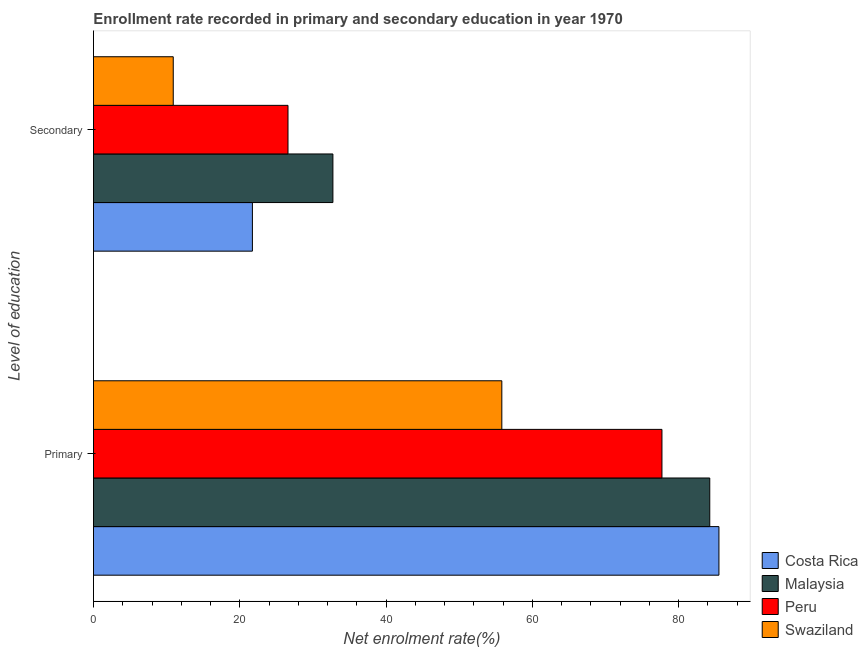How many different coloured bars are there?
Give a very brief answer. 4. How many groups of bars are there?
Offer a very short reply. 2. How many bars are there on the 2nd tick from the bottom?
Your response must be concise. 4. What is the label of the 2nd group of bars from the top?
Your response must be concise. Primary. What is the enrollment rate in secondary education in Malaysia?
Provide a succinct answer. 32.73. Across all countries, what is the maximum enrollment rate in primary education?
Your answer should be very brief. 85.5. Across all countries, what is the minimum enrollment rate in primary education?
Ensure brevity in your answer.  55.82. In which country was the enrollment rate in primary education maximum?
Your answer should be compact. Costa Rica. In which country was the enrollment rate in primary education minimum?
Offer a very short reply. Swaziland. What is the total enrollment rate in primary education in the graph?
Offer a terse response. 303.28. What is the difference between the enrollment rate in secondary education in Costa Rica and that in Malaysia?
Your answer should be very brief. -11. What is the difference between the enrollment rate in secondary education in Costa Rica and the enrollment rate in primary education in Swaziland?
Your response must be concise. -34.09. What is the average enrollment rate in secondary education per country?
Give a very brief answer. 22.99. What is the difference between the enrollment rate in primary education and enrollment rate in secondary education in Malaysia?
Ensure brevity in your answer.  51.51. What is the ratio of the enrollment rate in secondary education in Costa Rica to that in Malaysia?
Your response must be concise. 0.66. In how many countries, is the enrollment rate in secondary education greater than the average enrollment rate in secondary education taken over all countries?
Give a very brief answer. 2. What does the 4th bar from the bottom in Primary represents?
Keep it short and to the point. Swaziland. Are the values on the major ticks of X-axis written in scientific E-notation?
Provide a succinct answer. No. Does the graph contain any zero values?
Your answer should be compact. No. Does the graph contain grids?
Make the answer very short. No. How many legend labels are there?
Provide a succinct answer. 4. What is the title of the graph?
Provide a short and direct response. Enrollment rate recorded in primary and secondary education in year 1970. What is the label or title of the X-axis?
Offer a very short reply. Net enrolment rate(%). What is the label or title of the Y-axis?
Make the answer very short. Level of education. What is the Net enrolment rate(%) of Costa Rica in Primary?
Your answer should be compact. 85.5. What is the Net enrolment rate(%) of Malaysia in Primary?
Give a very brief answer. 84.25. What is the Net enrolment rate(%) in Peru in Primary?
Your answer should be very brief. 77.71. What is the Net enrolment rate(%) in Swaziland in Primary?
Ensure brevity in your answer.  55.82. What is the Net enrolment rate(%) of Costa Rica in Secondary?
Make the answer very short. 21.73. What is the Net enrolment rate(%) of Malaysia in Secondary?
Your answer should be compact. 32.73. What is the Net enrolment rate(%) of Peru in Secondary?
Offer a terse response. 26.59. What is the Net enrolment rate(%) of Swaziland in Secondary?
Your answer should be very brief. 10.9. Across all Level of education, what is the maximum Net enrolment rate(%) of Costa Rica?
Provide a short and direct response. 85.5. Across all Level of education, what is the maximum Net enrolment rate(%) of Malaysia?
Keep it short and to the point. 84.25. Across all Level of education, what is the maximum Net enrolment rate(%) in Peru?
Offer a very short reply. 77.71. Across all Level of education, what is the maximum Net enrolment rate(%) in Swaziland?
Give a very brief answer. 55.82. Across all Level of education, what is the minimum Net enrolment rate(%) of Costa Rica?
Ensure brevity in your answer.  21.73. Across all Level of education, what is the minimum Net enrolment rate(%) in Malaysia?
Offer a terse response. 32.73. Across all Level of education, what is the minimum Net enrolment rate(%) in Peru?
Your answer should be very brief. 26.59. Across all Level of education, what is the minimum Net enrolment rate(%) in Swaziland?
Offer a terse response. 10.9. What is the total Net enrolment rate(%) in Costa Rica in the graph?
Give a very brief answer. 107.23. What is the total Net enrolment rate(%) in Malaysia in the graph?
Offer a terse response. 116.98. What is the total Net enrolment rate(%) in Peru in the graph?
Make the answer very short. 104.3. What is the total Net enrolment rate(%) of Swaziland in the graph?
Offer a terse response. 66.73. What is the difference between the Net enrolment rate(%) of Costa Rica in Primary and that in Secondary?
Give a very brief answer. 63.77. What is the difference between the Net enrolment rate(%) of Malaysia in Primary and that in Secondary?
Your response must be concise. 51.51. What is the difference between the Net enrolment rate(%) in Peru in Primary and that in Secondary?
Your answer should be compact. 51.12. What is the difference between the Net enrolment rate(%) of Swaziland in Primary and that in Secondary?
Ensure brevity in your answer.  44.92. What is the difference between the Net enrolment rate(%) in Costa Rica in Primary and the Net enrolment rate(%) in Malaysia in Secondary?
Offer a very short reply. 52.77. What is the difference between the Net enrolment rate(%) of Costa Rica in Primary and the Net enrolment rate(%) of Peru in Secondary?
Give a very brief answer. 58.91. What is the difference between the Net enrolment rate(%) in Costa Rica in Primary and the Net enrolment rate(%) in Swaziland in Secondary?
Provide a succinct answer. 74.59. What is the difference between the Net enrolment rate(%) of Malaysia in Primary and the Net enrolment rate(%) of Peru in Secondary?
Give a very brief answer. 57.65. What is the difference between the Net enrolment rate(%) of Malaysia in Primary and the Net enrolment rate(%) of Swaziland in Secondary?
Keep it short and to the point. 73.34. What is the difference between the Net enrolment rate(%) in Peru in Primary and the Net enrolment rate(%) in Swaziland in Secondary?
Keep it short and to the point. 66.81. What is the average Net enrolment rate(%) in Costa Rica per Level of education?
Your answer should be compact. 53.61. What is the average Net enrolment rate(%) in Malaysia per Level of education?
Your answer should be very brief. 58.49. What is the average Net enrolment rate(%) of Peru per Level of education?
Your answer should be very brief. 52.15. What is the average Net enrolment rate(%) of Swaziland per Level of education?
Provide a succinct answer. 33.36. What is the difference between the Net enrolment rate(%) in Costa Rica and Net enrolment rate(%) in Malaysia in Primary?
Keep it short and to the point. 1.25. What is the difference between the Net enrolment rate(%) of Costa Rica and Net enrolment rate(%) of Peru in Primary?
Give a very brief answer. 7.79. What is the difference between the Net enrolment rate(%) in Costa Rica and Net enrolment rate(%) in Swaziland in Primary?
Your response must be concise. 29.68. What is the difference between the Net enrolment rate(%) of Malaysia and Net enrolment rate(%) of Peru in Primary?
Offer a very short reply. 6.53. What is the difference between the Net enrolment rate(%) of Malaysia and Net enrolment rate(%) of Swaziland in Primary?
Provide a succinct answer. 28.42. What is the difference between the Net enrolment rate(%) in Peru and Net enrolment rate(%) in Swaziland in Primary?
Your answer should be compact. 21.89. What is the difference between the Net enrolment rate(%) of Costa Rica and Net enrolment rate(%) of Malaysia in Secondary?
Provide a short and direct response. -11. What is the difference between the Net enrolment rate(%) of Costa Rica and Net enrolment rate(%) of Peru in Secondary?
Ensure brevity in your answer.  -4.86. What is the difference between the Net enrolment rate(%) in Costa Rica and Net enrolment rate(%) in Swaziland in Secondary?
Your answer should be compact. 10.82. What is the difference between the Net enrolment rate(%) of Malaysia and Net enrolment rate(%) of Peru in Secondary?
Keep it short and to the point. 6.14. What is the difference between the Net enrolment rate(%) in Malaysia and Net enrolment rate(%) in Swaziland in Secondary?
Your answer should be very brief. 21.83. What is the difference between the Net enrolment rate(%) in Peru and Net enrolment rate(%) in Swaziland in Secondary?
Give a very brief answer. 15.69. What is the ratio of the Net enrolment rate(%) in Costa Rica in Primary to that in Secondary?
Provide a short and direct response. 3.94. What is the ratio of the Net enrolment rate(%) of Malaysia in Primary to that in Secondary?
Ensure brevity in your answer.  2.57. What is the ratio of the Net enrolment rate(%) in Peru in Primary to that in Secondary?
Give a very brief answer. 2.92. What is the ratio of the Net enrolment rate(%) in Swaziland in Primary to that in Secondary?
Your answer should be very brief. 5.12. What is the difference between the highest and the second highest Net enrolment rate(%) in Costa Rica?
Offer a very short reply. 63.77. What is the difference between the highest and the second highest Net enrolment rate(%) in Malaysia?
Keep it short and to the point. 51.51. What is the difference between the highest and the second highest Net enrolment rate(%) in Peru?
Make the answer very short. 51.12. What is the difference between the highest and the second highest Net enrolment rate(%) in Swaziland?
Ensure brevity in your answer.  44.92. What is the difference between the highest and the lowest Net enrolment rate(%) in Costa Rica?
Offer a very short reply. 63.77. What is the difference between the highest and the lowest Net enrolment rate(%) in Malaysia?
Ensure brevity in your answer.  51.51. What is the difference between the highest and the lowest Net enrolment rate(%) of Peru?
Offer a very short reply. 51.12. What is the difference between the highest and the lowest Net enrolment rate(%) in Swaziland?
Provide a succinct answer. 44.92. 